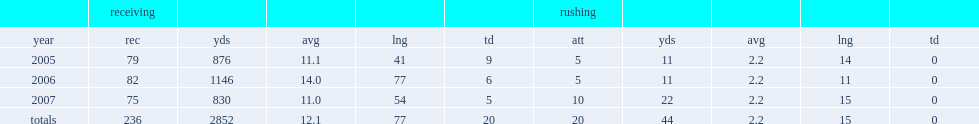How many receptions did earl bennett have in totals? 236.0. 